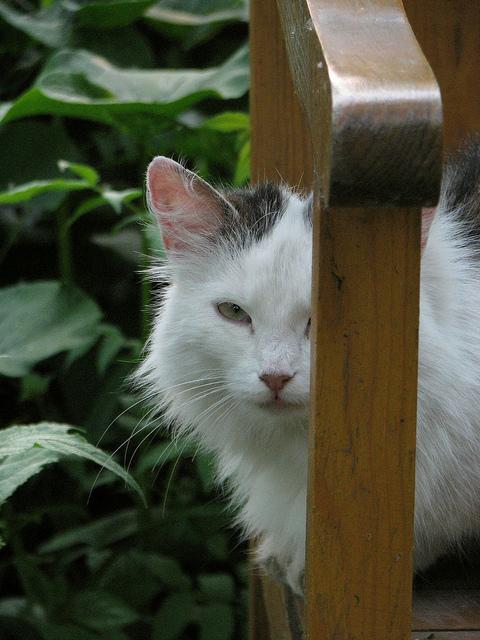What furniture is the cat sitting on?
Concise answer only. Chair. What color is this furry animal?
Concise answer only. White. What color are the leaves?
Write a very short answer. Green. 